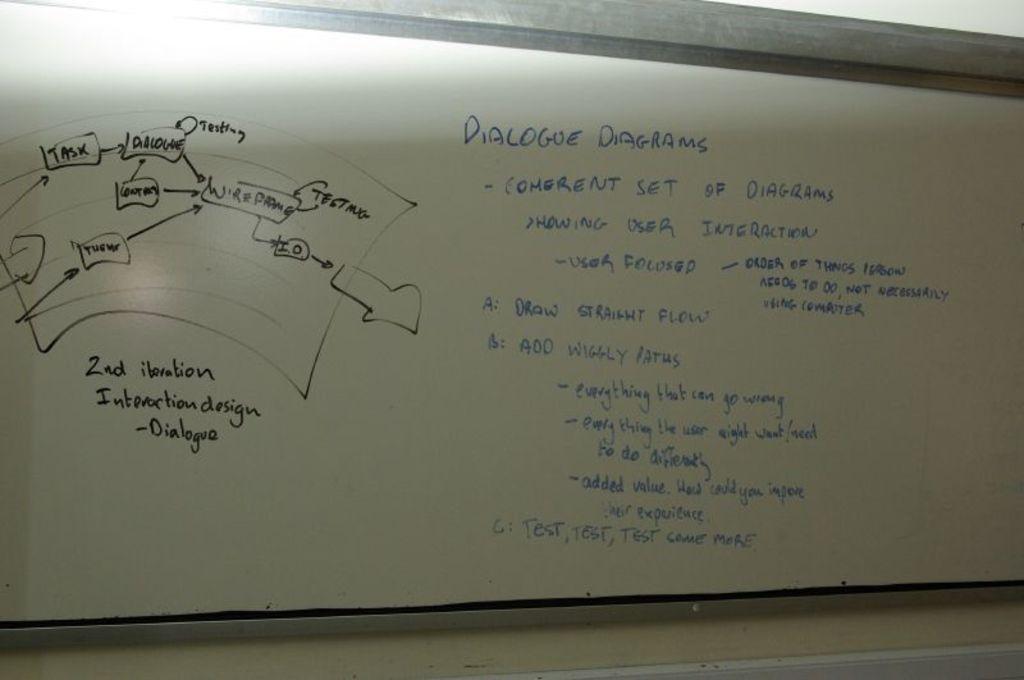What kind of diagram is this?
Offer a very short reply. Dialogue diagram. How many different colors are on this board?
Make the answer very short. 2. 